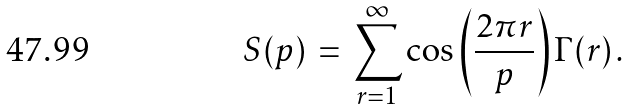Convert formula to latex. <formula><loc_0><loc_0><loc_500><loc_500>S ( p ) \, = \, \sum _ { r = 1 } ^ { \infty } \cos \left ( \frac { 2 \pi r } { p } \right ) \Gamma ( r ) \, .</formula> 